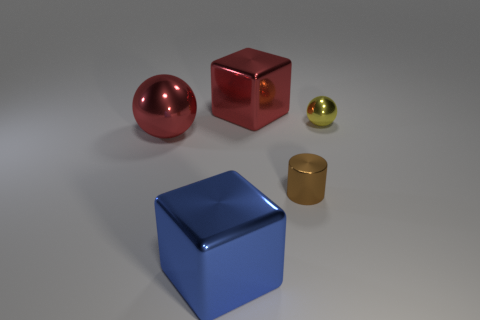Add 1 big blue shiny blocks. How many objects exist? 6 Subtract all spheres. How many objects are left? 3 Subtract 1 cubes. How many cubes are left? 1 Subtract all tiny cyan blocks. Subtract all tiny spheres. How many objects are left? 4 Add 4 blue blocks. How many blue blocks are left? 5 Add 4 small shiny cylinders. How many small shiny cylinders exist? 5 Subtract 1 blue cubes. How many objects are left? 4 Subtract all yellow cylinders. Subtract all blue cubes. How many cylinders are left? 1 Subtract all yellow cylinders. How many yellow spheres are left? 1 